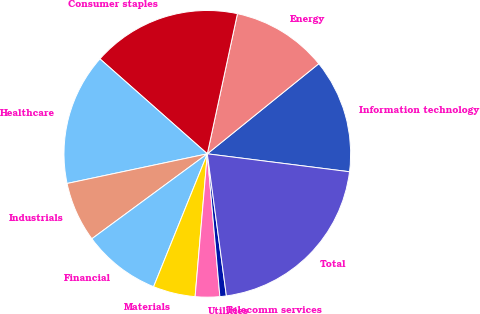Convert chart. <chart><loc_0><loc_0><loc_500><loc_500><pie_chart><fcel>Information technology<fcel>Energy<fcel>Consumer staples<fcel>Healthcare<fcel>Industrials<fcel>Financial<fcel>Materials<fcel>Utilities<fcel>Telecomm services<fcel>Total<nl><fcel>12.82%<fcel>10.81%<fcel>16.85%<fcel>14.84%<fcel>6.78%<fcel>8.79%<fcel>4.76%<fcel>2.75%<fcel>0.73%<fcel>20.88%<nl></chart> 